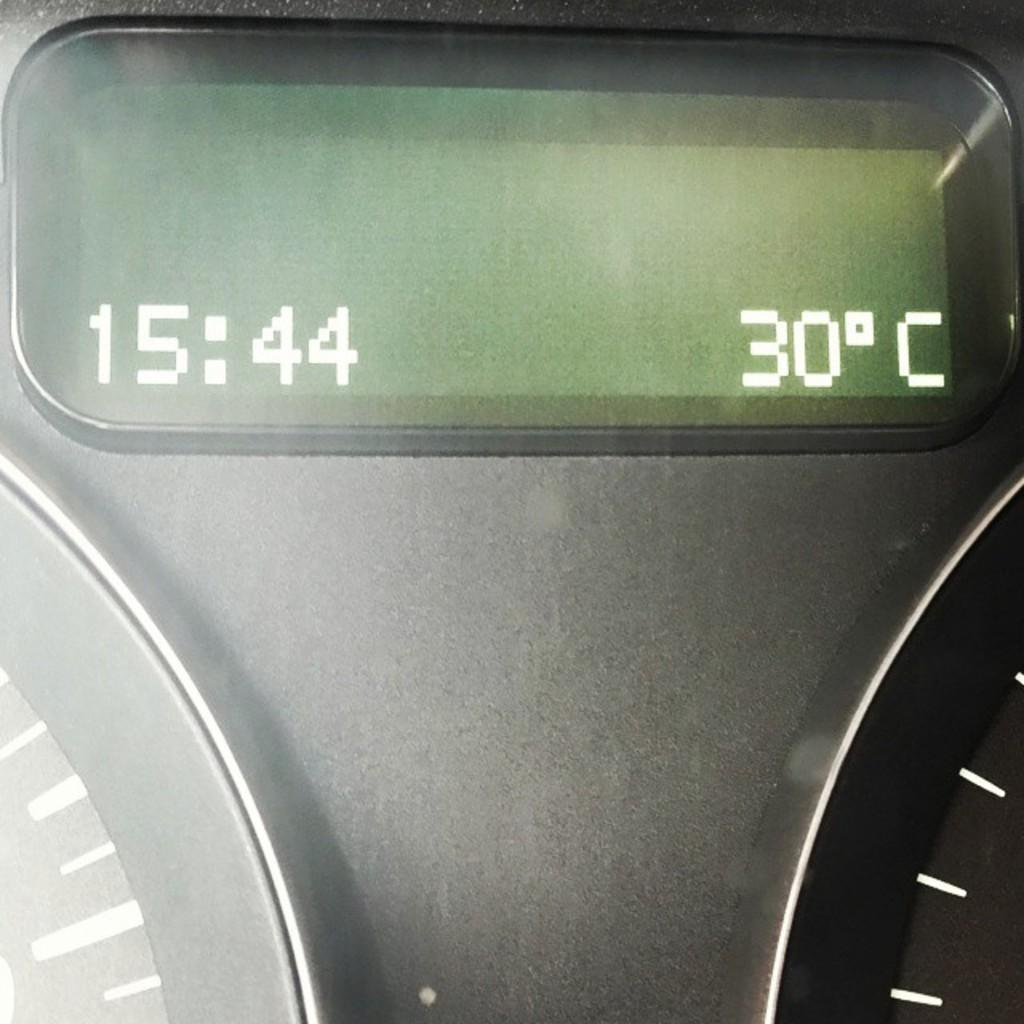<image>
Write a terse but informative summary of the picture. The screen on a vehicles dashboard says that the time is 15:44 and the temperature is 30C 